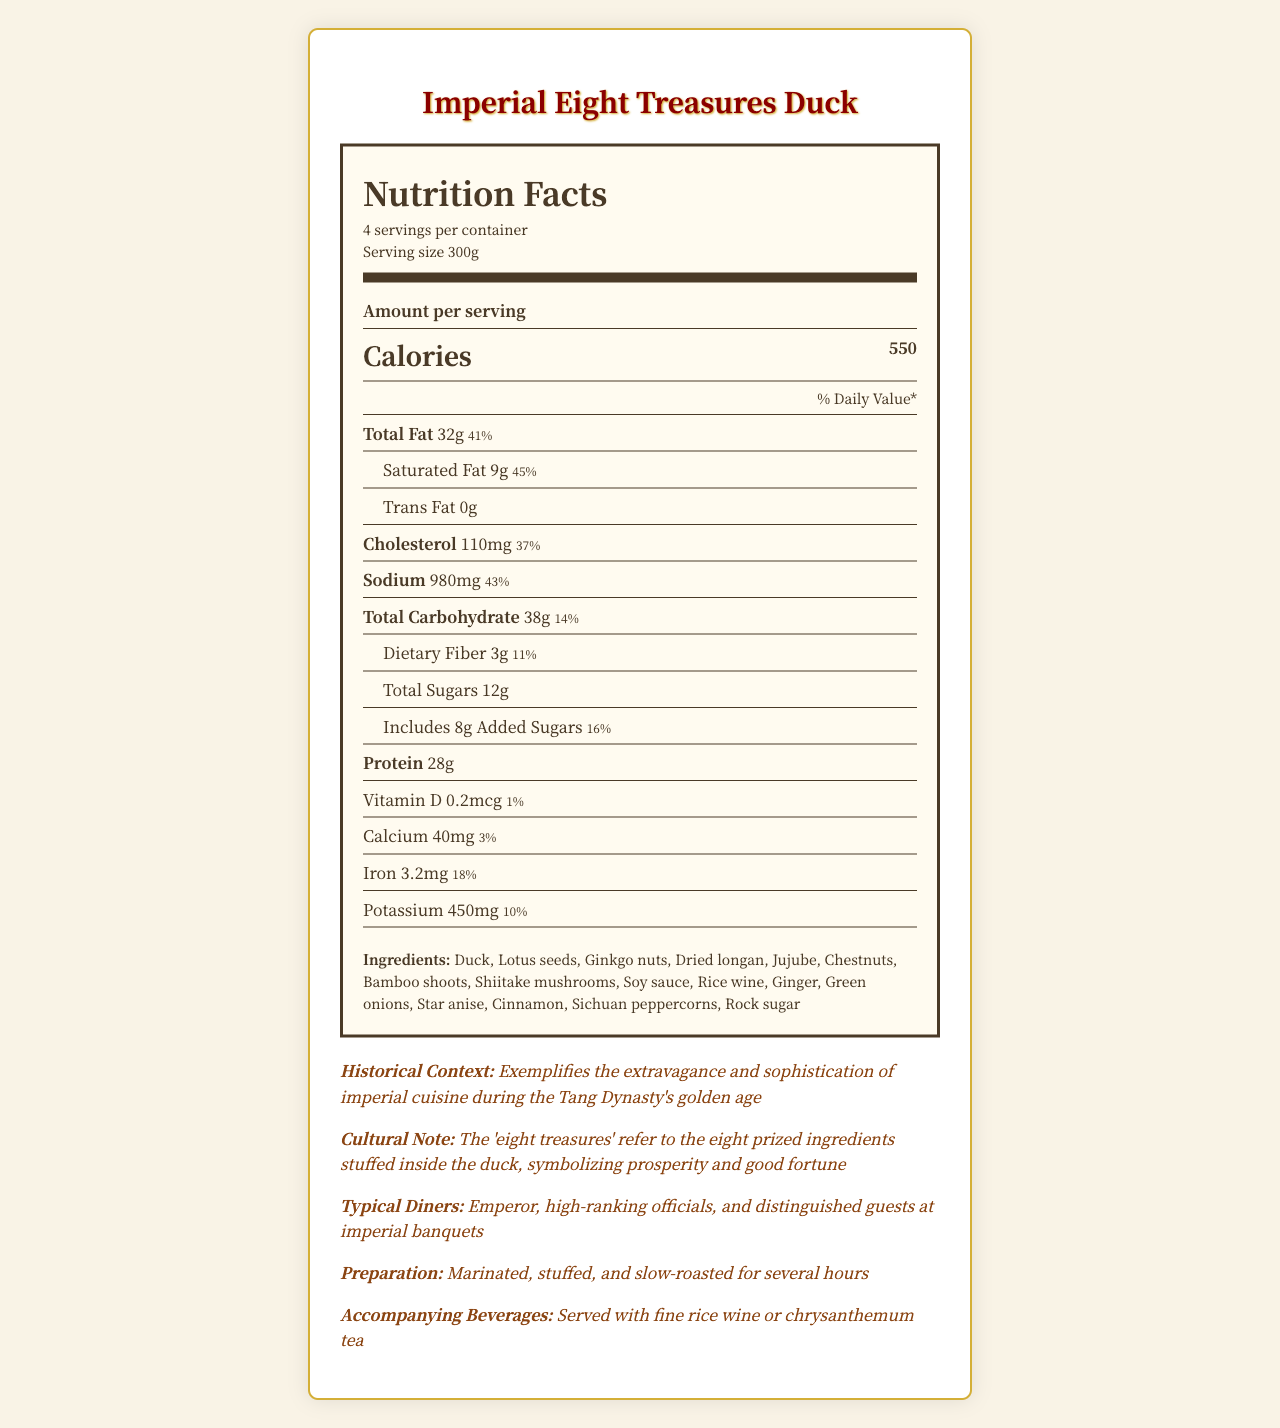What is the serving size of the Imperial Eight Treasures Duck? The serving size is directly stated in the nutrition facts section of the document.
Answer: 300g How much protein is in one serving of the dish? The protein content is listed under the nutrition information for one serving.
Answer: 28 grams Who were the typical diners of this dish during the Tang Dynasty? This information is provided in the historical context section under the heading "Typical Diners".
Answer: Emperor, high-ranking officials, and distinguished guests at imperial banquets What is the daily value percentage for sodium in one serving? The daily value percentage for sodium is listed in the nutrition facts table.
Answer: 43% What is the total carbohydrate content per serving? The total carbohydrate content is listed under the nutrition facts.
Answer: 38 grams What dynasty is associated with the Imperial Eight Treasures Duck? A. Han Dynasty B. Tang Dynasty C. Ming Dynasty D. Qing Dynasty The historical context mentions that the dish is associated with the Tang Dynasty.
Answer: B. Tang Dynasty Which of the following is not an ingredient in the dish? A. Duck B. Ginkgo nuts C. Broccoli D. Star anise Broccoli is not listed in the ingredients section of the document.
Answer: C. Broccoli Is there any trans fat in the dish? The nutrition facts state that there is 0 grams of trans fat per serving.
Answer: No Describe the historical and cultural significance of the Imperial Eight Treasures Duck. The historical context section provides detailed information on both the culinary significance and cultural notes.
Answer: The dish exemplifies the extravagance and sophistication of imperial cuisine during the Tang Dynasty's golden age. The 'eight treasures' refer to the eight prized ingredients stuffed inside the duck, symbolizing prosperity and good fortune. How is the Imperial Eight Treasures Duck typically prepared? The preparation method is explicitly stated in the document.
Answer: Marinated, stuffed, and slow-roasted for several hours What is the daily value percentage of iron in one serving of the dish? The daily value percentage for iron is listed in the nutrition facts.
Answer: 18% How many servings are there per container for the Imperial Eight Treasures Duck? The document states that there are 4 servings per container.
Answer: 4 What is the accompanying beverage traditionally served with the dish? This is noted in the historical context section under "Accompanying Beverages".
Answer: Fine rice wine or chrysanthemum tea What vitamins or minerals are present in trace amounts in the dish? Vitamin D has a daily value percentage of just 1% as listed in the nutrition facts.
Answer: Vitamin D What year range does the Tang Dynasty cover? The year range for the Tang Dynasty is provided in the historical context section.
Answer: 618-907 CE What is the culinary significance of the 'eight treasures'? The cultural notes in the historical context section explain that the 'eight treasures' symbolize prosperity and good fortune.
Answer: Symbolizes prosperity and good fortune What type of fat has the highest daily value percentage in one serving? Saturated fat has a daily value percentage of 45%, which is higher than the percentage for total fat.
Answer: Saturated fat What is the daily value percentage for dietary fiber in the dish? The daily value percentage for dietary fiber is listed in the nutrition facts.
Answer: 11% Can we determine the exact preparation time for the dish? The document states the preparation method but does not specify the exact duration of "several hours".
Answer: Not enough information What is the total calorie count for all servings in the container? Each serving has 550 calories, and there are 4 servings per container: 550 x 4 = 2200.
Answer: 2200 calories What are some of the aromatic spices used in the preparation of the dish? These spices are listed in the ingredients section of the document.
Answer: Star anise, cinnamon, Sichuan peppercorns How much calcium is in one serving of the dish? The amount of calcium is listed under the nutrition facts.
Answer: 40 milligrams 